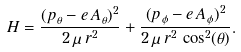<formula> <loc_0><loc_0><loc_500><loc_500>H = \frac { ( p _ { \theta } - e \, A _ { \theta } ) ^ { 2 } } { 2 \, \mu \, r ^ { 2 } } + \frac { ( p _ { \phi } - e \, A _ { \phi } ) ^ { 2 } } { 2 \, \mu \, r ^ { 2 } \, \cos ^ { 2 } ( \theta ) } .</formula> 